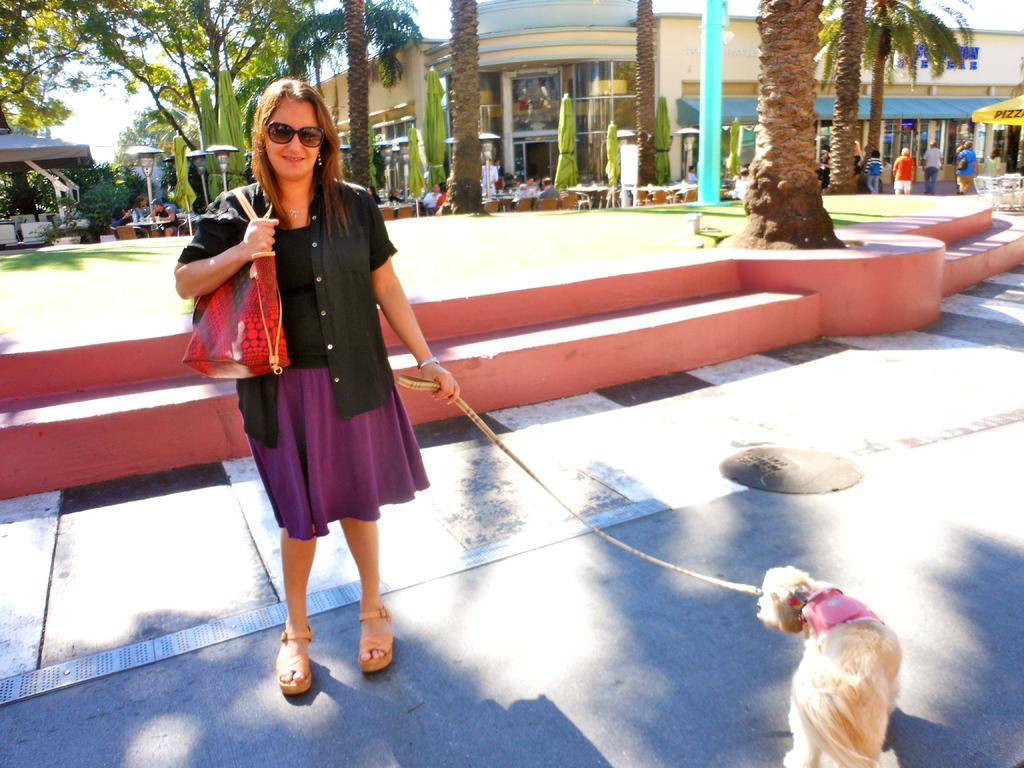Who is present in the image? There is a woman in the image. What is the woman doing in the image? The woman is standing with her dog in the image. Where are they located? They are on a road in the image. What can be seen in the background of the image? There are trees, tables and chairs, and shops in the background of the image. What type of snakes can be seen slithering around the woman's feet in the image? There are no snakes present in the image; the woman is standing with her dog on a road. Can you tell me where the scarecrow is located in the image? There is no scarecrow present in the image. 